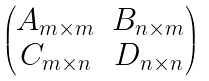Convert formula to latex. <formula><loc_0><loc_0><loc_500><loc_500>\begin{pmatrix} A _ { m \times m } & B _ { n \times m } \\ C _ { m \times n } & D _ { n \times n } \end{pmatrix}</formula> 